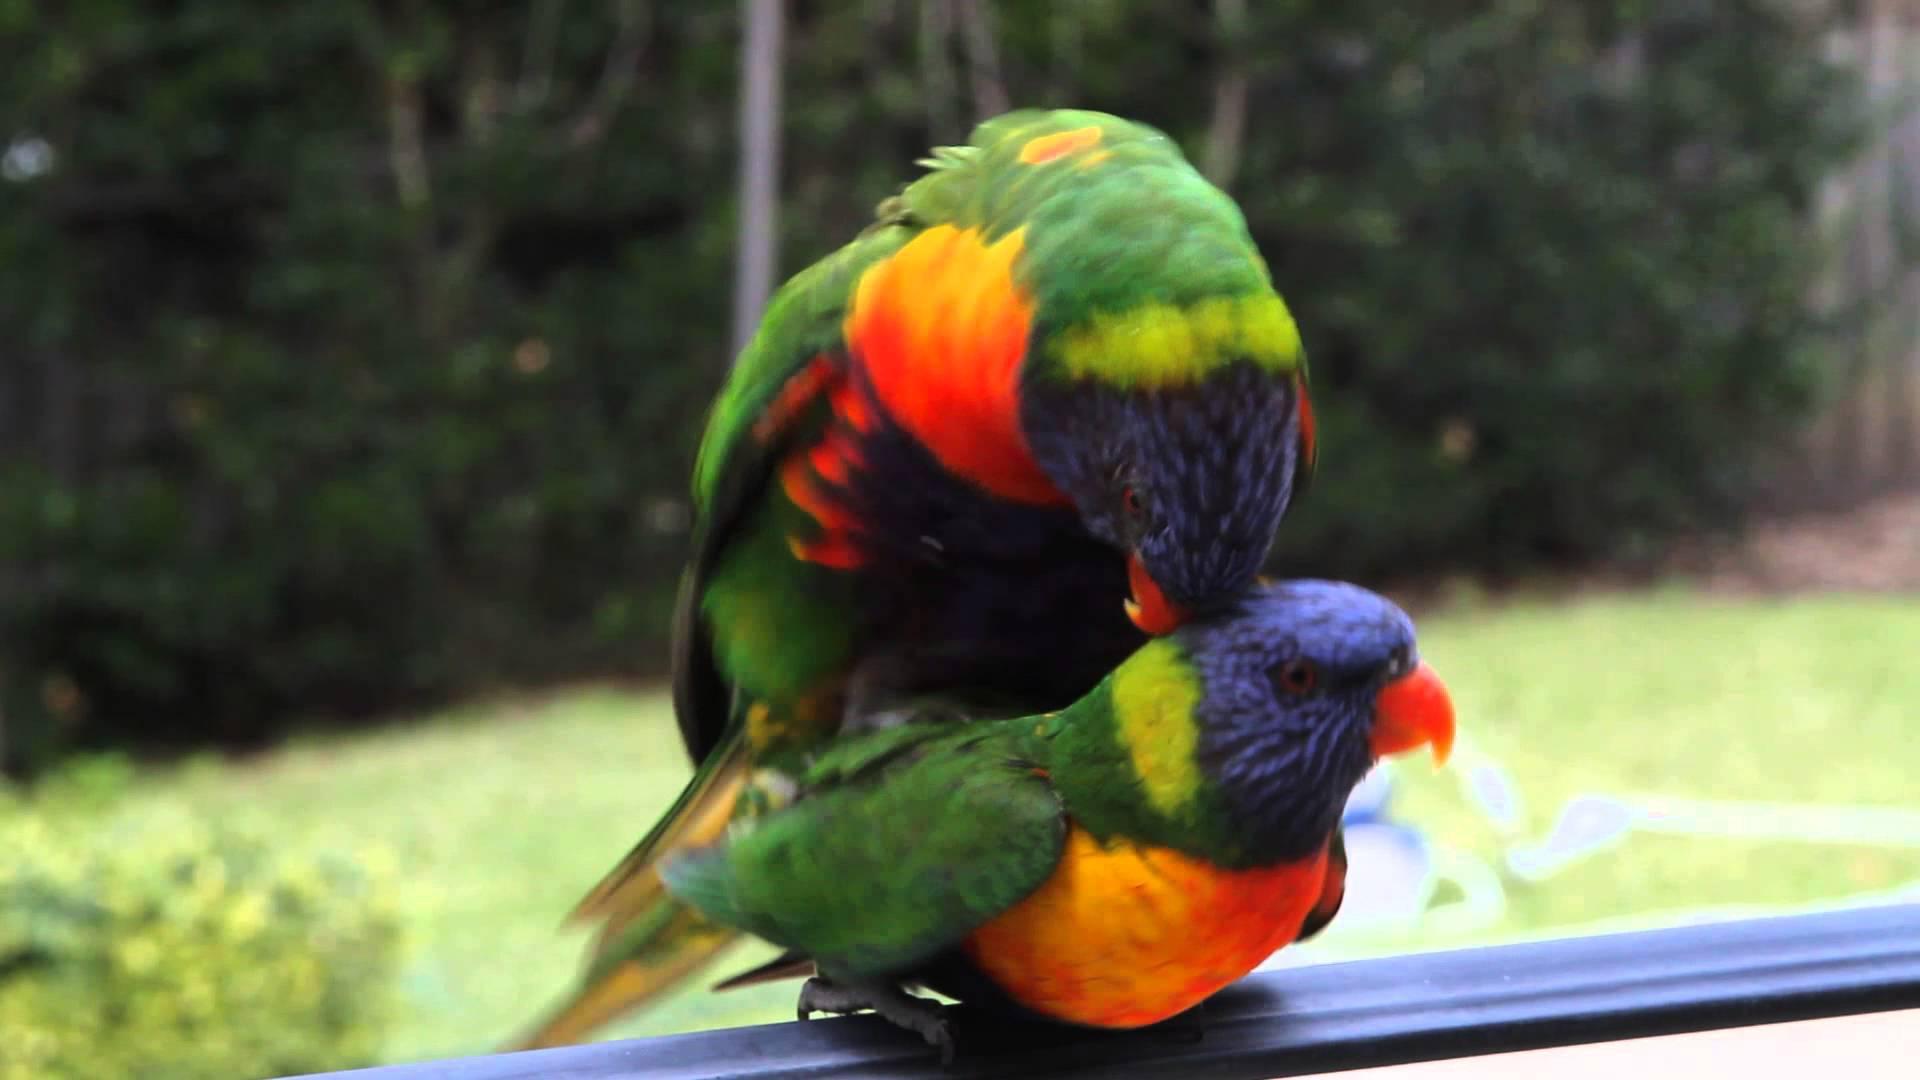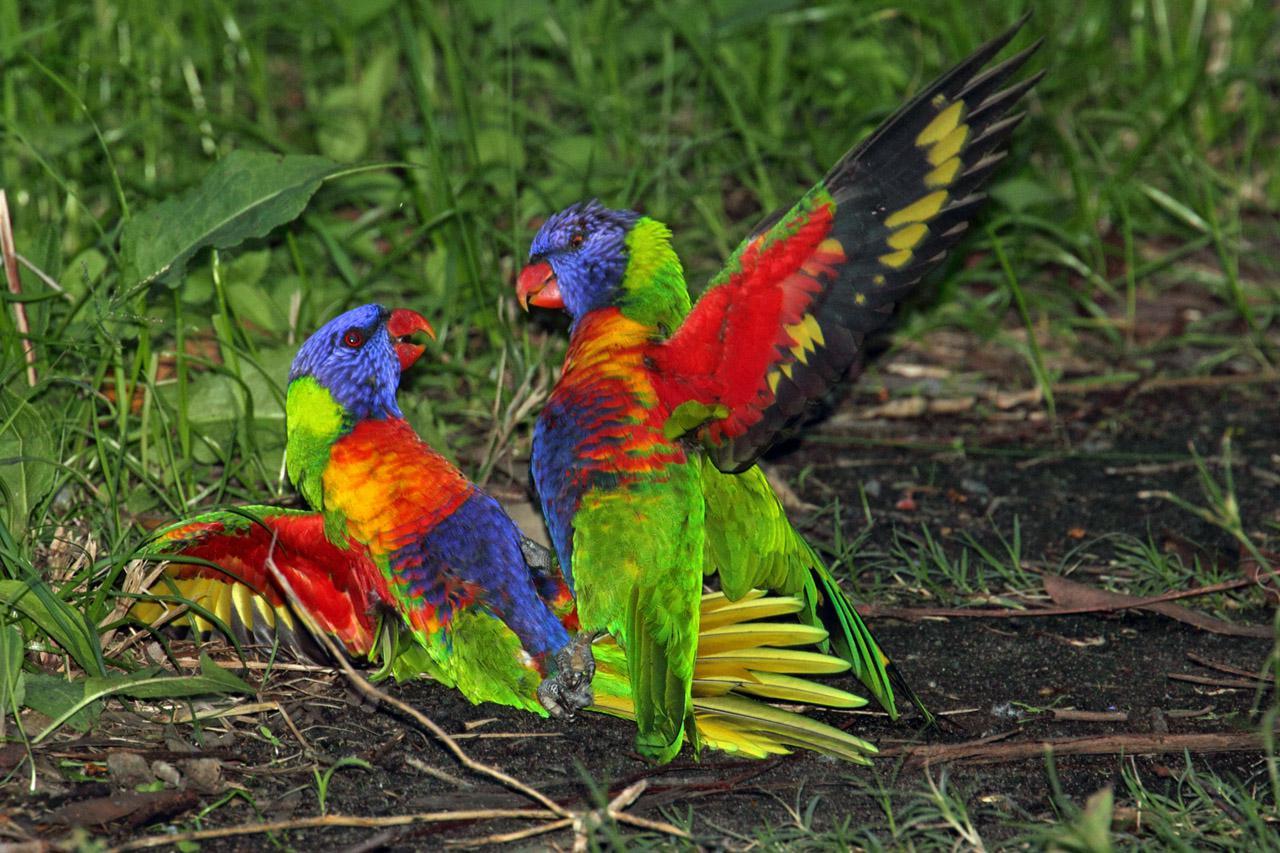The first image is the image on the left, the second image is the image on the right. Considering the images on both sides, is "In at least one of the images there are four or more rainbow lorikeets gathered together." valid? Answer yes or no. No. The first image is the image on the left, the second image is the image on the right. Evaluate the accuracy of this statement regarding the images: "There is at most four rainbow lorikeets.". Is it true? Answer yes or no. Yes. 